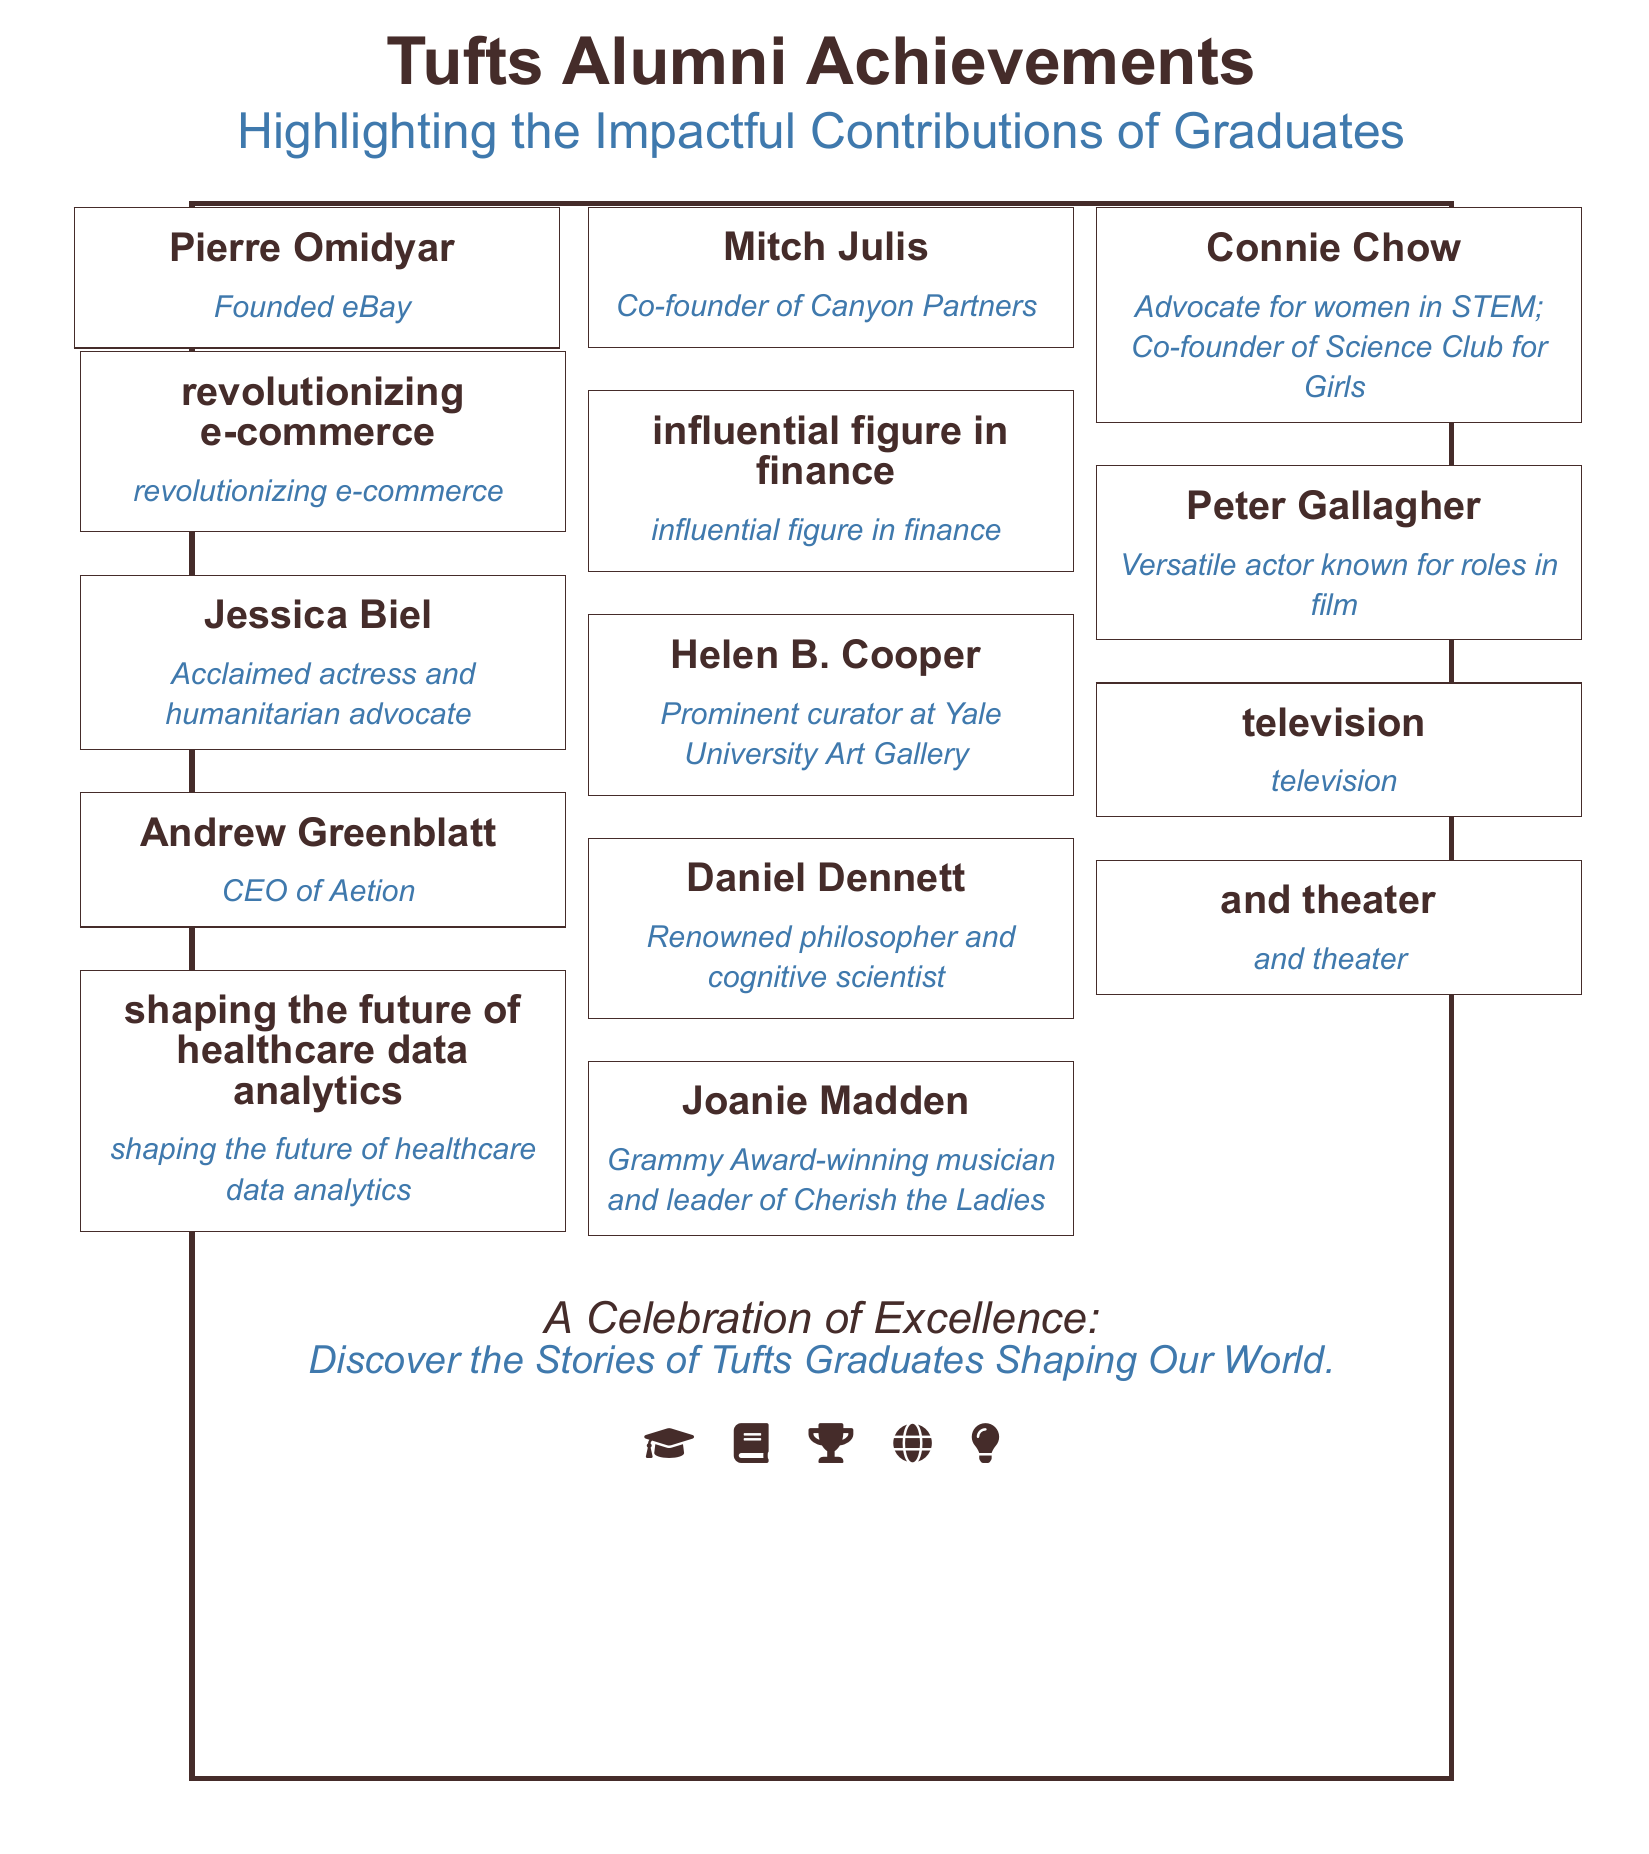What is the title of the document? The title is presented prominently at the top of the document.
Answer: Tufts Alumni Achievements How many distinguished alumni are highlighted in the document? The document lists multiple alumni, specifically noted in the collage section.
Answer: 9 Who is known for founding eBay? This information can be found in the list of alumni and their accomplishments.
Answer: Pierre Omidyar Which Tufts alumna is an acclaimed actress? The document includes brief descriptions of the alumni's achievements, including professions.
Answer: Jessica Biel What is the primary color used for the document’s title? The title's color is specified in the document.
Answer: Tufts Brown Which alumnus is associated with healthcare data analytics? The relevant alumnus's name is mentioned in the achievements section.
Answer: Andrew Greenblatt What type of cap icon is included at the bottom of the document? The types of icons used at the bottom indicate several themes relevant to education.
Answer: Graduation Cap What does the subtitle of the document emphasize? The subtitle highlights the overarching theme of the document regarding contributions of graduates.
Answer: Impactful Contributions of Graduates What is the purpose of the collage in the document? The collage serves to visually represent the achievements and contributions of notable alumni.
Answer: Celebration of Excellence 